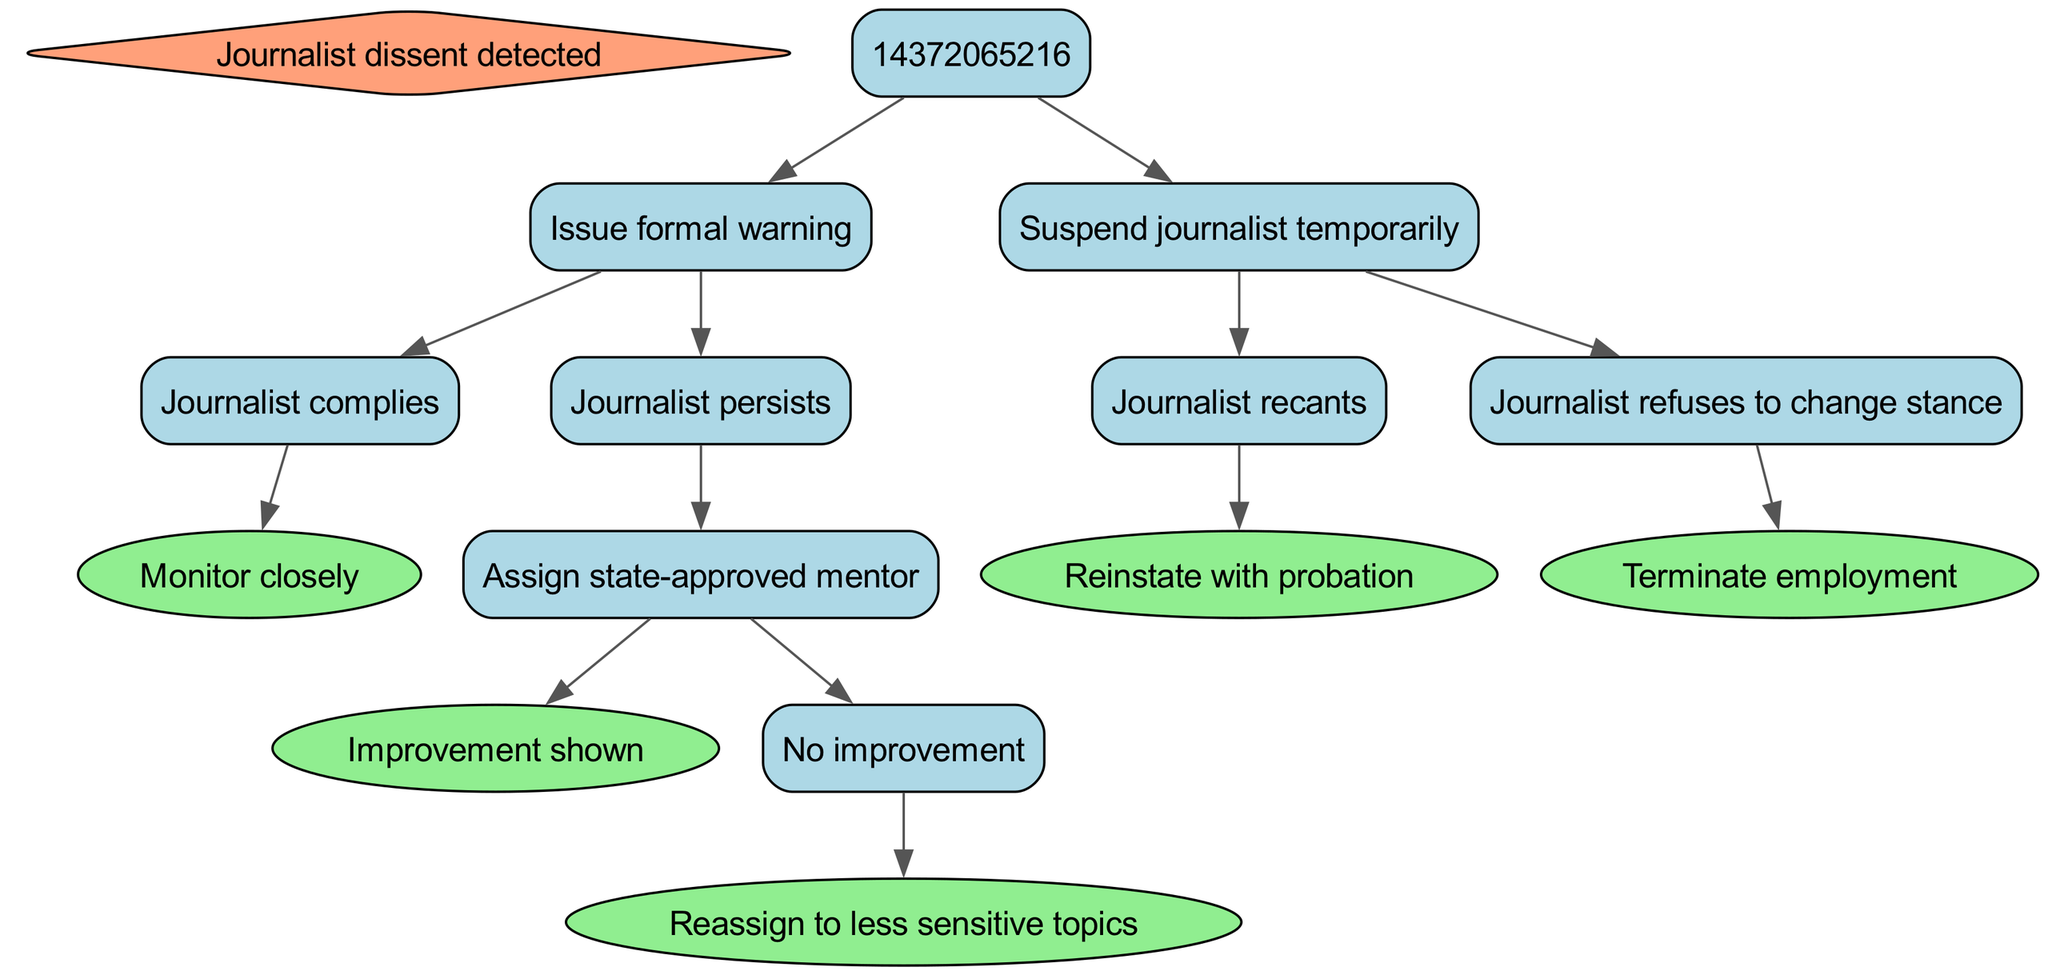What is the root node of the decision tree? The root node is the starting point of the decision tree, representing the primary event or condition being evaluated. In this case, it is labeled "Journalist dissent detected."
Answer: Journalist dissent detected How many branches are there from the root node? The root node branches into two distinct paths, representing different initial responses to the detection of journalist dissent. This means there are two branches.
Answer: 2 What happens if the journalist complies after a formal warning? If the journalist complies after receiving a formal warning, the next step in the decision tree is to "Monitor closely," indicating that the situation will continue to be observed.
Answer: Monitor closely What is the outcome if the journalist refuses to change stance after suspension? If the journalist refuses to change their stance after being suspended, the decision tree indicates that the outcome is to "Terminate employment," meaning the journalist will be let go from their position.
Answer: Terminate employment How many leaf nodes are present in the entire diagram? By examining the decision tree, we can count the total number of leaf nodes, which represent final outcomes without further branching. There are four leaf nodes in total.
Answer: 4 What is required if the journalist persists after a warning? If the journalist persists after receiving a formal warning, the next action in the decision tree is to "Assign state-approved mentor," indicating a step to provide support to the journalist for improvement.
Answer: Assign state-approved mentor What is the action taken if no improvement is shown after assigning a mentor? Should the assigned mentor determine that no improvement is achieved, the proceeding action is to "Reassign to less sensitive topics," which entails changing the journalist’s reporting focus to mitigate risk.
Answer: Reassign to less sensitive topics What node represents a reinstate action after a recant? If a journalist who was suspended later recants, the tree specifies that they will "Reinstate with probation," which indicates a conditional return to their position.
Answer: Reinstate with probation 